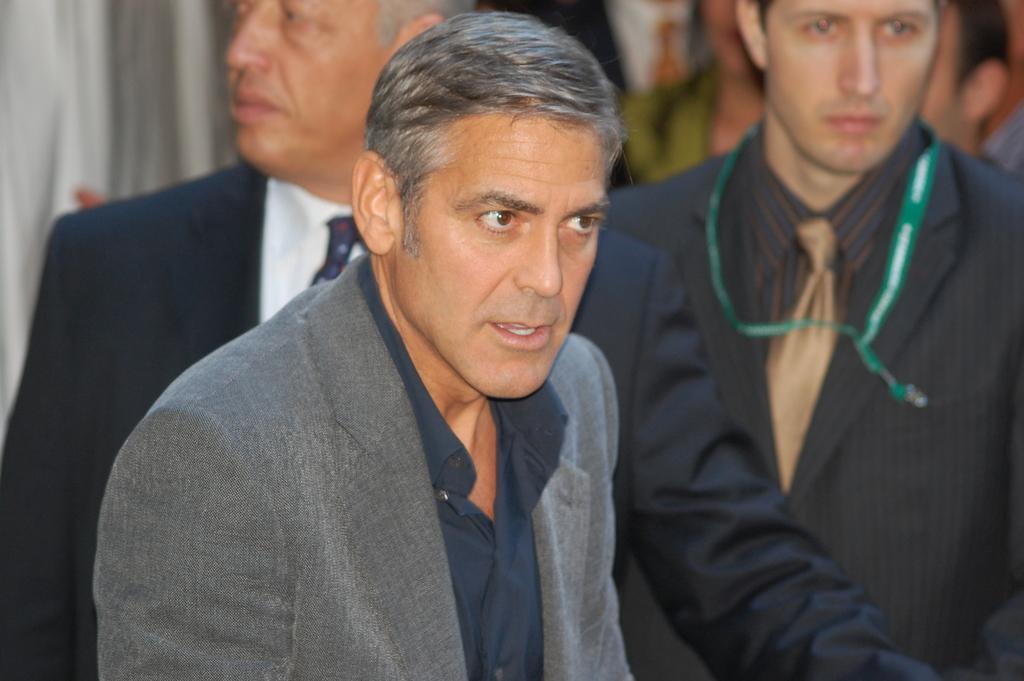Could you give a brief overview of what you see in this image? In this picture we can observe three members. All of them were men and wearing coats. There is a man wearing a green color tag in his neck on the right side. In the background there are some people standing. 